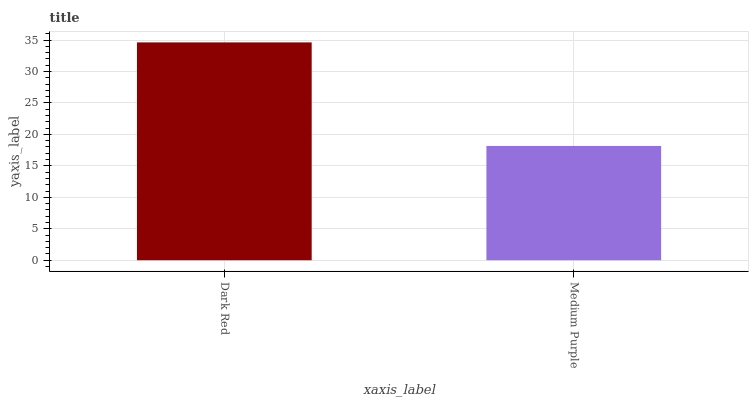Is Medium Purple the minimum?
Answer yes or no. Yes. Is Dark Red the maximum?
Answer yes or no. Yes. Is Medium Purple the maximum?
Answer yes or no. No. Is Dark Red greater than Medium Purple?
Answer yes or no. Yes. Is Medium Purple less than Dark Red?
Answer yes or no. Yes. Is Medium Purple greater than Dark Red?
Answer yes or no. No. Is Dark Red less than Medium Purple?
Answer yes or no. No. Is Dark Red the high median?
Answer yes or no. Yes. Is Medium Purple the low median?
Answer yes or no. Yes. Is Medium Purple the high median?
Answer yes or no. No. Is Dark Red the low median?
Answer yes or no. No. 